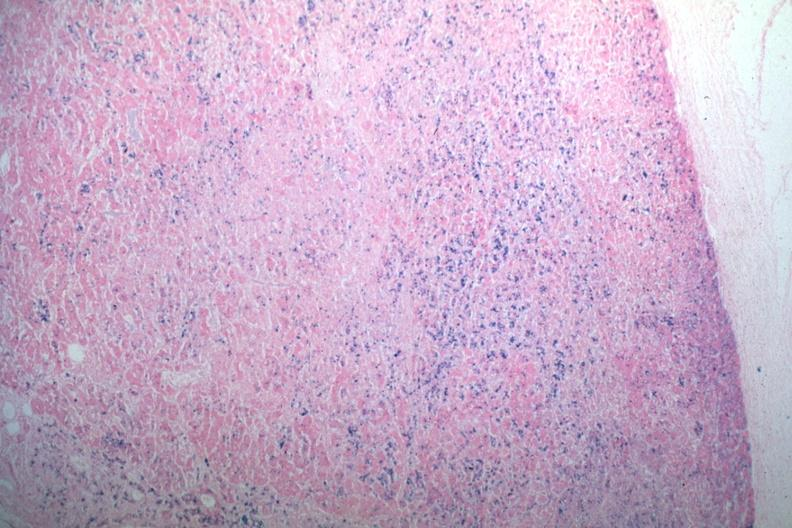does iron stain abundant iron?
Answer the question using a single word or phrase. Yes 